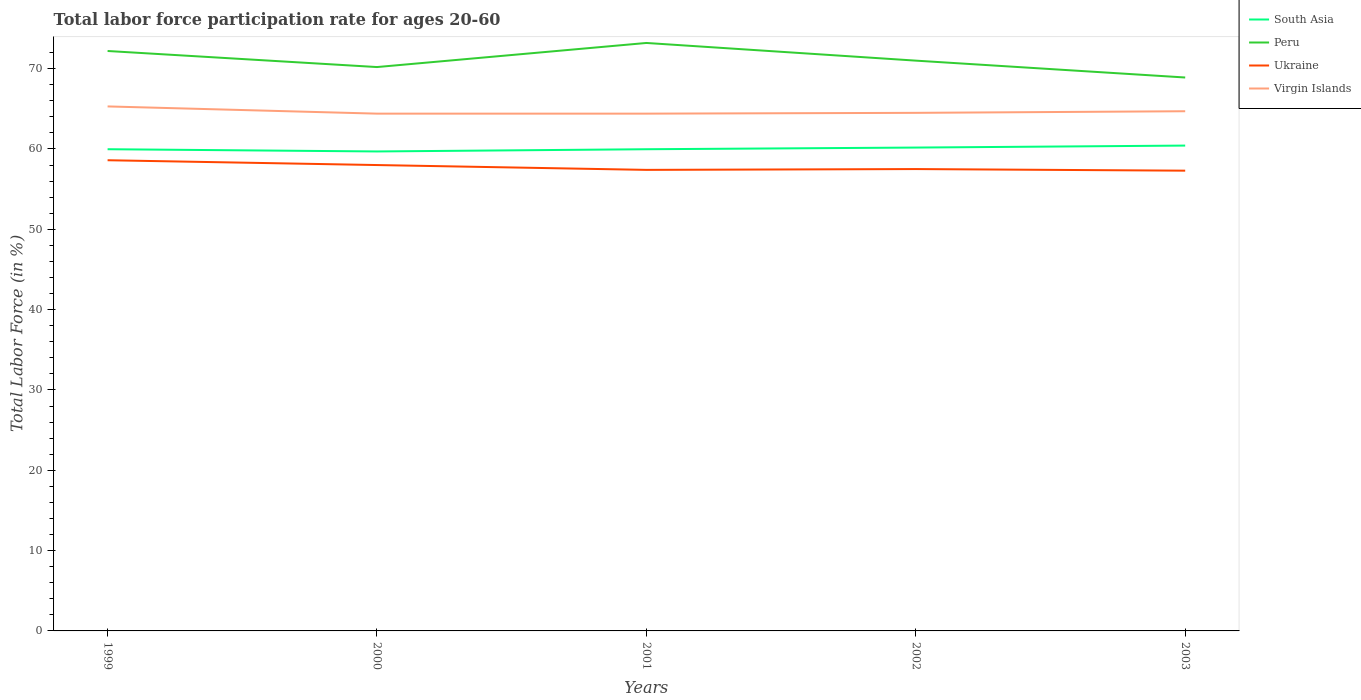How many different coloured lines are there?
Offer a very short reply. 4. Does the line corresponding to South Asia intersect with the line corresponding to Peru?
Provide a short and direct response. No. Is the number of lines equal to the number of legend labels?
Keep it short and to the point. Yes. Across all years, what is the maximum labor force participation rate in South Asia?
Give a very brief answer. 59.69. In which year was the labor force participation rate in Ukraine maximum?
Offer a terse response. 2003. What is the total labor force participation rate in Peru in the graph?
Ensure brevity in your answer.  1.2. What is the difference between the highest and the second highest labor force participation rate in South Asia?
Provide a short and direct response. 0.73. What is the difference between the highest and the lowest labor force participation rate in Ukraine?
Your answer should be compact. 2. How many lines are there?
Your answer should be compact. 4. What is the difference between two consecutive major ticks on the Y-axis?
Give a very brief answer. 10. Are the values on the major ticks of Y-axis written in scientific E-notation?
Your answer should be very brief. No. Does the graph contain any zero values?
Your answer should be compact. No. How many legend labels are there?
Keep it short and to the point. 4. What is the title of the graph?
Your answer should be compact. Total labor force participation rate for ages 20-60. Does "Latin America(developing only)" appear as one of the legend labels in the graph?
Provide a short and direct response. No. What is the label or title of the X-axis?
Offer a terse response. Years. What is the Total Labor Force (in %) in South Asia in 1999?
Your answer should be compact. 59.97. What is the Total Labor Force (in %) of Peru in 1999?
Keep it short and to the point. 72.2. What is the Total Labor Force (in %) of Ukraine in 1999?
Provide a short and direct response. 58.6. What is the Total Labor Force (in %) in Virgin Islands in 1999?
Provide a succinct answer. 65.3. What is the Total Labor Force (in %) of South Asia in 2000?
Provide a short and direct response. 59.69. What is the Total Labor Force (in %) in Peru in 2000?
Provide a succinct answer. 70.2. What is the Total Labor Force (in %) of Ukraine in 2000?
Make the answer very short. 58. What is the Total Labor Force (in %) in Virgin Islands in 2000?
Offer a very short reply. 64.4. What is the Total Labor Force (in %) in South Asia in 2001?
Provide a short and direct response. 59.97. What is the Total Labor Force (in %) of Peru in 2001?
Your answer should be compact. 73.2. What is the Total Labor Force (in %) of Ukraine in 2001?
Your answer should be compact. 57.4. What is the Total Labor Force (in %) of Virgin Islands in 2001?
Make the answer very short. 64.4. What is the Total Labor Force (in %) in South Asia in 2002?
Keep it short and to the point. 60.18. What is the Total Labor Force (in %) of Ukraine in 2002?
Keep it short and to the point. 57.5. What is the Total Labor Force (in %) of Virgin Islands in 2002?
Your answer should be compact. 64.5. What is the Total Labor Force (in %) in South Asia in 2003?
Your response must be concise. 60.43. What is the Total Labor Force (in %) of Peru in 2003?
Provide a succinct answer. 68.9. What is the Total Labor Force (in %) in Ukraine in 2003?
Offer a very short reply. 57.3. What is the Total Labor Force (in %) of Virgin Islands in 2003?
Offer a very short reply. 64.7. Across all years, what is the maximum Total Labor Force (in %) of South Asia?
Make the answer very short. 60.43. Across all years, what is the maximum Total Labor Force (in %) in Peru?
Keep it short and to the point. 73.2. Across all years, what is the maximum Total Labor Force (in %) of Ukraine?
Offer a terse response. 58.6. Across all years, what is the maximum Total Labor Force (in %) in Virgin Islands?
Your answer should be very brief. 65.3. Across all years, what is the minimum Total Labor Force (in %) in South Asia?
Offer a terse response. 59.69. Across all years, what is the minimum Total Labor Force (in %) in Peru?
Offer a very short reply. 68.9. Across all years, what is the minimum Total Labor Force (in %) of Ukraine?
Offer a terse response. 57.3. Across all years, what is the minimum Total Labor Force (in %) in Virgin Islands?
Make the answer very short. 64.4. What is the total Total Labor Force (in %) in South Asia in the graph?
Offer a terse response. 300.24. What is the total Total Labor Force (in %) of Peru in the graph?
Offer a terse response. 355.5. What is the total Total Labor Force (in %) in Ukraine in the graph?
Offer a terse response. 288.8. What is the total Total Labor Force (in %) in Virgin Islands in the graph?
Provide a succinct answer. 323.3. What is the difference between the Total Labor Force (in %) in South Asia in 1999 and that in 2000?
Provide a short and direct response. 0.28. What is the difference between the Total Labor Force (in %) of Virgin Islands in 1999 and that in 2000?
Provide a succinct answer. 0.9. What is the difference between the Total Labor Force (in %) in South Asia in 1999 and that in 2002?
Make the answer very short. -0.21. What is the difference between the Total Labor Force (in %) in Virgin Islands in 1999 and that in 2002?
Ensure brevity in your answer.  0.8. What is the difference between the Total Labor Force (in %) in South Asia in 1999 and that in 2003?
Offer a very short reply. -0.45. What is the difference between the Total Labor Force (in %) in South Asia in 2000 and that in 2001?
Give a very brief answer. -0.28. What is the difference between the Total Labor Force (in %) of Peru in 2000 and that in 2001?
Your answer should be very brief. -3. What is the difference between the Total Labor Force (in %) of South Asia in 2000 and that in 2002?
Ensure brevity in your answer.  -0.48. What is the difference between the Total Labor Force (in %) of Peru in 2000 and that in 2002?
Your answer should be very brief. -0.8. What is the difference between the Total Labor Force (in %) in Ukraine in 2000 and that in 2002?
Ensure brevity in your answer.  0.5. What is the difference between the Total Labor Force (in %) in South Asia in 2000 and that in 2003?
Provide a short and direct response. -0.73. What is the difference between the Total Labor Force (in %) of South Asia in 2001 and that in 2002?
Offer a very short reply. -0.21. What is the difference between the Total Labor Force (in %) in Peru in 2001 and that in 2002?
Offer a very short reply. 2.2. What is the difference between the Total Labor Force (in %) of Ukraine in 2001 and that in 2002?
Ensure brevity in your answer.  -0.1. What is the difference between the Total Labor Force (in %) in South Asia in 2001 and that in 2003?
Your answer should be very brief. -0.46. What is the difference between the Total Labor Force (in %) of Virgin Islands in 2001 and that in 2003?
Keep it short and to the point. -0.3. What is the difference between the Total Labor Force (in %) in South Asia in 2002 and that in 2003?
Make the answer very short. -0.25. What is the difference between the Total Labor Force (in %) in Peru in 2002 and that in 2003?
Offer a terse response. 2.1. What is the difference between the Total Labor Force (in %) in Ukraine in 2002 and that in 2003?
Provide a short and direct response. 0.2. What is the difference between the Total Labor Force (in %) in South Asia in 1999 and the Total Labor Force (in %) in Peru in 2000?
Provide a short and direct response. -10.23. What is the difference between the Total Labor Force (in %) in South Asia in 1999 and the Total Labor Force (in %) in Ukraine in 2000?
Your response must be concise. 1.97. What is the difference between the Total Labor Force (in %) of South Asia in 1999 and the Total Labor Force (in %) of Virgin Islands in 2000?
Your answer should be compact. -4.43. What is the difference between the Total Labor Force (in %) of Peru in 1999 and the Total Labor Force (in %) of Ukraine in 2000?
Provide a short and direct response. 14.2. What is the difference between the Total Labor Force (in %) of South Asia in 1999 and the Total Labor Force (in %) of Peru in 2001?
Your answer should be very brief. -13.23. What is the difference between the Total Labor Force (in %) in South Asia in 1999 and the Total Labor Force (in %) in Ukraine in 2001?
Ensure brevity in your answer.  2.57. What is the difference between the Total Labor Force (in %) in South Asia in 1999 and the Total Labor Force (in %) in Virgin Islands in 2001?
Ensure brevity in your answer.  -4.43. What is the difference between the Total Labor Force (in %) in Peru in 1999 and the Total Labor Force (in %) in Ukraine in 2001?
Your response must be concise. 14.8. What is the difference between the Total Labor Force (in %) of South Asia in 1999 and the Total Labor Force (in %) of Peru in 2002?
Offer a terse response. -11.03. What is the difference between the Total Labor Force (in %) of South Asia in 1999 and the Total Labor Force (in %) of Ukraine in 2002?
Keep it short and to the point. 2.47. What is the difference between the Total Labor Force (in %) in South Asia in 1999 and the Total Labor Force (in %) in Virgin Islands in 2002?
Your answer should be very brief. -4.53. What is the difference between the Total Labor Force (in %) of South Asia in 1999 and the Total Labor Force (in %) of Peru in 2003?
Your response must be concise. -8.93. What is the difference between the Total Labor Force (in %) in South Asia in 1999 and the Total Labor Force (in %) in Ukraine in 2003?
Your answer should be very brief. 2.67. What is the difference between the Total Labor Force (in %) of South Asia in 1999 and the Total Labor Force (in %) of Virgin Islands in 2003?
Your answer should be very brief. -4.73. What is the difference between the Total Labor Force (in %) in Peru in 1999 and the Total Labor Force (in %) in Ukraine in 2003?
Give a very brief answer. 14.9. What is the difference between the Total Labor Force (in %) in Ukraine in 1999 and the Total Labor Force (in %) in Virgin Islands in 2003?
Offer a terse response. -6.1. What is the difference between the Total Labor Force (in %) in South Asia in 2000 and the Total Labor Force (in %) in Peru in 2001?
Provide a succinct answer. -13.51. What is the difference between the Total Labor Force (in %) in South Asia in 2000 and the Total Labor Force (in %) in Ukraine in 2001?
Provide a short and direct response. 2.29. What is the difference between the Total Labor Force (in %) of South Asia in 2000 and the Total Labor Force (in %) of Virgin Islands in 2001?
Keep it short and to the point. -4.71. What is the difference between the Total Labor Force (in %) in Peru in 2000 and the Total Labor Force (in %) in Virgin Islands in 2001?
Ensure brevity in your answer.  5.8. What is the difference between the Total Labor Force (in %) of Ukraine in 2000 and the Total Labor Force (in %) of Virgin Islands in 2001?
Offer a terse response. -6.4. What is the difference between the Total Labor Force (in %) of South Asia in 2000 and the Total Labor Force (in %) of Peru in 2002?
Provide a succinct answer. -11.31. What is the difference between the Total Labor Force (in %) in South Asia in 2000 and the Total Labor Force (in %) in Ukraine in 2002?
Your answer should be very brief. 2.19. What is the difference between the Total Labor Force (in %) of South Asia in 2000 and the Total Labor Force (in %) of Virgin Islands in 2002?
Your answer should be very brief. -4.81. What is the difference between the Total Labor Force (in %) of Peru in 2000 and the Total Labor Force (in %) of Virgin Islands in 2002?
Provide a short and direct response. 5.7. What is the difference between the Total Labor Force (in %) of South Asia in 2000 and the Total Labor Force (in %) of Peru in 2003?
Ensure brevity in your answer.  -9.21. What is the difference between the Total Labor Force (in %) of South Asia in 2000 and the Total Labor Force (in %) of Ukraine in 2003?
Your response must be concise. 2.39. What is the difference between the Total Labor Force (in %) in South Asia in 2000 and the Total Labor Force (in %) in Virgin Islands in 2003?
Keep it short and to the point. -5.01. What is the difference between the Total Labor Force (in %) of Peru in 2000 and the Total Labor Force (in %) of Virgin Islands in 2003?
Your response must be concise. 5.5. What is the difference between the Total Labor Force (in %) of South Asia in 2001 and the Total Labor Force (in %) of Peru in 2002?
Your response must be concise. -11.03. What is the difference between the Total Labor Force (in %) in South Asia in 2001 and the Total Labor Force (in %) in Ukraine in 2002?
Provide a short and direct response. 2.47. What is the difference between the Total Labor Force (in %) in South Asia in 2001 and the Total Labor Force (in %) in Virgin Islands in 2002?
Ensure brevity in your answer.  -4.53. What is the difference between the Total Labor Force (in %) in South Asia in 2001 and the Total Labor Force (in %) in Peru in 2003?
Your answer should be very brief. -8.93. What is the difference between the Total Labor Force (in %) of South Asia in 2001 and the Total Labor Force (in %) of Ukraine in 2003?
Your answer should be compact. 2.67. What is the difference between the Total Labor Force (in %) in South Asia in 2001 and the Total Labor Force (in %) in Virgin Islands in 2003?
Give a very brief answer. -4.73. What is the difference between the Total Labor Force (in %) of Peru in 2001 and the Total Labor Force (in %) of Ukraine in 2003?
Offer a very short reply. 15.9. What is the difference between the Total Labor Force (in %) in South Asia in 2002 and the Total Labor Force (in %) in Peru in 2003?
Offer a terse response. -8.72. What is the difference between the Total Labor Force (in %) of South Asia in 2002 and the Total Labor Force (in %) of Ukraine in 2003?
Offer a very short reply. 2.88. What is the difference between the Total Labor Force (in %) in South Asia in 2002 and the Total Labor Force (in %) in Virgin Islands in 2003?
Keep it short and to the point. -4.52. What is the difference between the Total Labor Force (in %) in Peru in 2002 and the Total Labor Force (in %) in Ukraine in 2003?
Provide a short and direct response. 13.7. What is the average Total Labor Force (in %) of South Asia per year?
Your answer should be compact. 60.05. What is the average Total Labor Force (in %) of Peru per year?
Offer a terse response. 71.1. What is the average Total Labor Force (in %) of Ukraine per year?
Give a very brief answer. 57.76. What is the average Total Labor Force (in %) in Virgin Islands per year?
Provide a succinct answer. 64.66. In the year 1999, what is the difference between the Total Labor Force (in %) in South Asia and Total Labor Force (in %) in Peru?
Provide a short and direct response. -12.23. In the year 1999, what is the difference between the Total Labor Force (in %) in South Asia and Total Labor Force (in %) in Ukraine?
Keep it short and to the point. 1.37. In the year 1999, what is the difference between the Total Labor Force (in %) in South Asia and Total Labor Force (in %) in Virgin Islands?
Provide a succinct answer. -5.33. In the year 1999, what is the difference between the Total Labor Force (in %) in Peru and Total Labor Force (in %) in Virgin Islands?
Your answer should be compact. 6.9. In the year 1999, what is the difference between the Total Labor Force (in %) in Ukraine and Total Labor Force (in %) in Virgin Islands?
Provide a short and direct response. -6.7. In the year 2000, what is the difference between the Total Labor Force (in %) in South Asia and Total Labor Force (in %) in Peru?
Your answer should be very brief. -10.51. In the year 2000, what is the difference between the Total Labor Force (in %) of South Asia and Total Labor Force (in %) of Ukraine?
Ensure brevity in your answer.  1.69. In the year 2000, what is the difference between the Total Labor Force (in %) of South Asia and Total Labor Force (in %) of Virgin Islands?
Keep it short and to the point. -4.71. In the year 2000, what is the difference between the Total Labor Force (in %) of Peru and Total Labor Force (in %) of Ukraine?
Your answer should be compact. 12.2. In the year 2001, what is the difference between the Total Labor Force (in %) of South Asia and Total Labor Force (in %) of Peru?
Your answer should be compact. -13.23. In the year 2001, what is the difference between the Total Labor Force (in %) in South Asia and Total Labor Force (in %) in Ukraine?
Keep it short and to the point. 2.57. In the year 2001, what is the difference between the Total Labor Force (in %) of South Asia and Total Labor Force (in %) of Virgin Islands?
Provide a succinct answer. -4.43. In the year 2002, what is the difference between the Total Labor Force (in %) in South Asia and Total Labor Force (in %) in Peru?
Offer a very short reply. -10.82. In the year 2002, what is the difference between the Total Labor Force (in %) in South Asia and Total Labor Force (in %) in Ukraine?
Give a very brief answer. 2.68. In the year 2002, what is the difference between the Total Labor Force (in %) of South Asia and Total Labor Force (in %) of Virgin Islands?
Make the answer very short. -4.32. In the year 2002, what is the difference between the Total Labor Force (in %) in Peru and Total Labor Force (in %) in Ukraine?
Offer a terse response. 13.5. In the year 2002, what is the difference between the Total Labor Force (in %) in Peru and Total Labor Force (in %) in Virgin Islands?
Your response must be concise. 6.5. In the year 2002, what is the difference between the Total Labor Force (in %) in Ukraine and Total Labor Force (in %) in Virgin Islands?
Give a very brief answer. -7. In the year 2003, what is the difference between the Total Labor Force (in %) of South Asia and Total Labor Force (in %) of Peru?
Your response must be concise. -8.47. In the year 2003, what is the difference between the Total Labor Force (in %) of South Asia and Total Labor Force (in %) of Ukraine?
Provide a succinct answer. 3.13. In the year 2003, what is the difference between the Total Labor Force (in %) of South Asia and Total Labor Force (in %) of Virgin Islands?
Your response must be concise. -4.27. In the year 2003, what is the difference between the Total Labor Force (in %) in Peru and Total Labor Force (in %) in Ukraine?
Keep it short and to the point. 11.6. In the year 2003, what is the difference between the Total Labor Force (in %) in Ukraine and Total Labor Force (in %) in Virgin Islands?
Keep it short and to the point. -7.4. What is the ratio of the Total Labor Force (in %) of South Asia in 1999 to that in 2000?
Provide a succinct answer. 1. What is the ratio of the Total Labor Force (in %) of Peru in 1999 to that in 2000?
Provide a succinct answer. 1.03. What is the ratio of the Total Labor Force (in %) of Ukraine in 1999 to that in 2000?
Ensure brevity in your answer.  1.01. What is the ratio of the Total Labor Force (in %) in Virgin Islands in 1999 to that in 2000?
Offer a very short reply. 1.01. What is the ratio of the Total Labor Force (in %) of South Asia in 1999 to that in 2001?
Provide a succinct answer. 1. What is the ratio of the Total Labor Force (in %) of Peru in 1999 to that in 2001?
Give a very brief answer. 0.99. What is the ratio of the Total Labor Force (in %) in Ukraine in 1999 to that in 2001?
Provide a succinct answer. 1.02. What is the ratio of the Total Labor Force (in %) in Virgin Islands in 1999 to that in 2001?
Your response must be concise. 1.01. What is the ratio of the Total Labor Force (in %) in South Asia in 1999 to that in 2002?
Offer a very short reply. 1. What is the ratio of the Total Labor Force (in %) of Peru in 1999 to that in 2002?
Your answer should be compact. 1.02. What is the ratio of the Total Labor Force (in %) in Ukraine in 1999 to that in 2002?
Your response must be concise. 1.02. What is the ratio of the Total Labor Force (in %) of Virgin Islands in 1999 to that in 2002?
Make the answer very short. 1.01. What is the ratio of the Total Labor Force (in %) in Peru in 1999 to that in 2003?
Make the answer very short. 1.05. What is the ratio of the Total Labor Force (in %) of Ukraine in 1999 to that in 2003?
Offer a terse response. 1.02. What is the ratio of the Total Labor Force (in %) of Virgin Islands in 1999 to that in 2003?
Ensure brevity in your answer.  1.01. What is the ratio of the Total Labor Force (in %) in Peru in 2000 to that in 2001?
Give a very brief answer. 0.96. What is the ratio of the Total Labor Force (in %) of Ukraine in 2000 to that in 2001?
Provide a succinct answer. 1.01. What is the ratio of the Total Labor Force (in %) in Virgin Islands in 2000 to that in 2001?
Offer a terse response. 1. What is the ratio of the Total Labor Force (in %) in South Asia in 2000 to that in 2002?
Give a very brief answer. 0.99. What is the ratio of the Total Labor Force (in %) in Peru in 2000 to that in 2002?
Offer a very short reply. 0.99. What is the ratio of the Total Labor Force (in %) in Ukraine in 2000 to that in 2002?
Make the answer very short. 1.01. What is the ratio of the Total Labor Force (in %) of South Asia in 2000 to that in 2003?
Make the answer very short. 0.99. What is the ratio of the Total Labor Force (in %) in Peru in 2000 to that in 2003?
Offer a very short reply. 1.02. What is the ratio of the Total Labor Force (in %) in Ukraine in 2000 to that in 2003?
Your answer should be compact. 1.01. What is the ratio of the Total Labor Force (in %) of South Asia in 2001 to that in 2002?
Keep it short and to the point. 1. What is the ratio of the Total Labor Force (in %) of Peru in 2001 to that in 2002?
Your answer should be very brief. 1.03. What is the ratio of the Total Labor Force (in %) of South Asia in 2001 to that in 2003?
Offer a terse response. 0.99. What is the ratio of the Total Labor Force (in %) in Peru in 2001 to that in 2003?
Your answer should be very brief. 1.06. What is the ratio of the Total Labor Force (in %) in Virgin Islands in 2001 to that in 2003?
Your answer should be compact. 1. What is the ratio of the Total Labor Force (in %) in South Asia in 2002 to that in 2003?
Your answer should be very brief. 1. What is the ratio of the Total Labor Force (in %) in Peru in 2002 to that in 2003?
Make the answer very short. 1.03. What is the ratio of the Total Labor Force (in %) of Virgin Islands in 2002 to that in 2003?
Your answer should be compact. 1. What is the difference between the highest and the second highest Total Labor Force (in %) in South Asia?
Provide a succinct answer. 0.25. What is the difference between the highest and the second highest Total Labor Force (in %) of Virgin Islands?
Make the answer very short. 0.6. What is the difference between the highest and the lowest Total Labor Force (in %) of South Asia?
Provide a succinct answer. 0.73. 